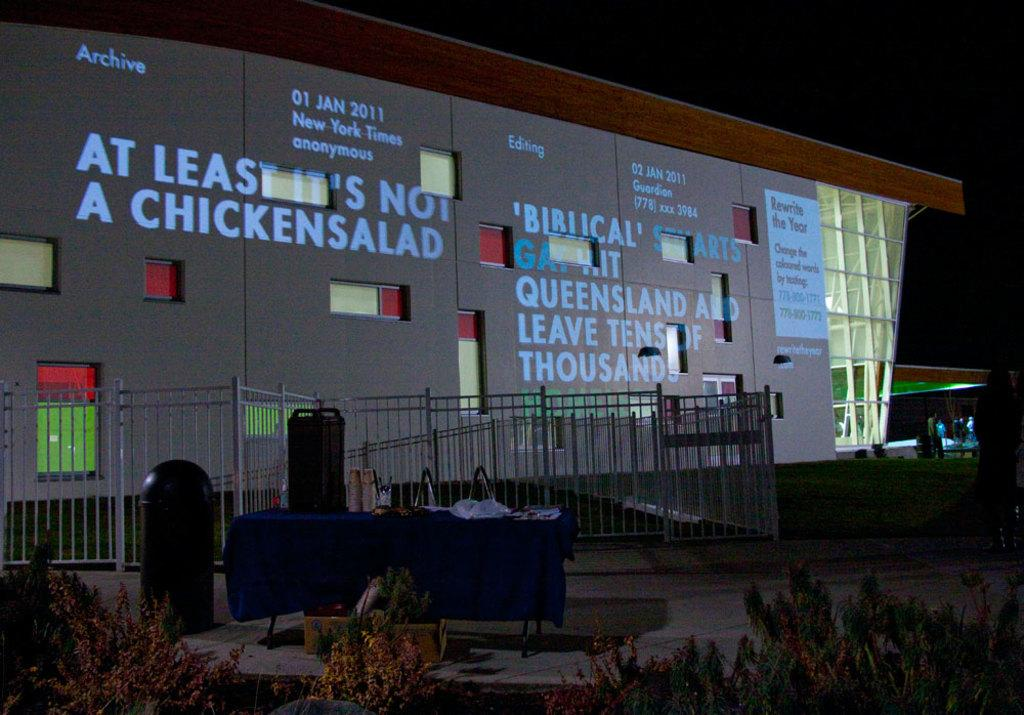What type of living organisms can be seen in the image? Plants are visible in the image. What type of structure can be seen in the image? There is a fence and a building with some text in the image. Who or what is present in the image? There are people and objects in the image. How would you describe the lighting in the image? The background of the image is dark. How many rabbits can be seen in the image? There are no rabbits present in the image. How long does it take for the minute hand to move in the image? There is no clock or time-related object in the image, so it's not possible to determine the movement of a minute hand. 